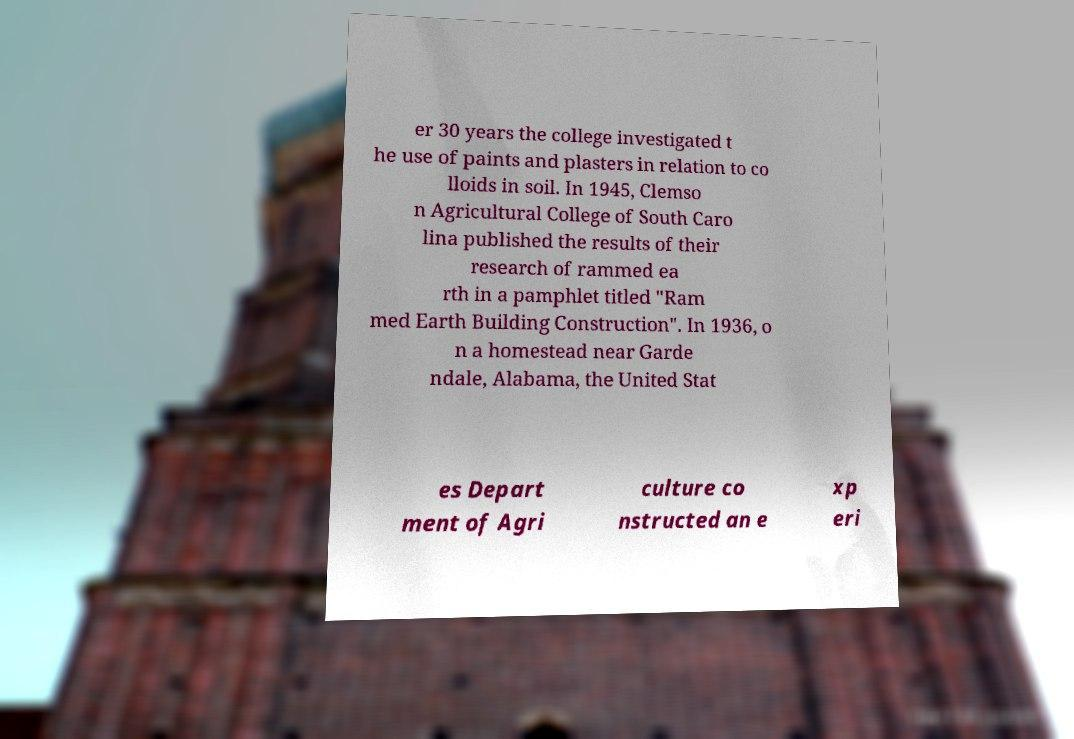There's text embedded in this image that I need extracted. Can you transcribe it verbatim? er 30 years the college investigated t he use of paints and plasters in relation to co lloids in soil. In 1945, Clemso n Agricultural College of South Caro lina published the results of their research of rammed ea rth in a pamphlet titled "Ram med Earth Building Construction". In 1936, o n a homestead near Garde ndale, Alabama, the United Stat es Depart ment of Agri culture co nstructed an e xp eri 